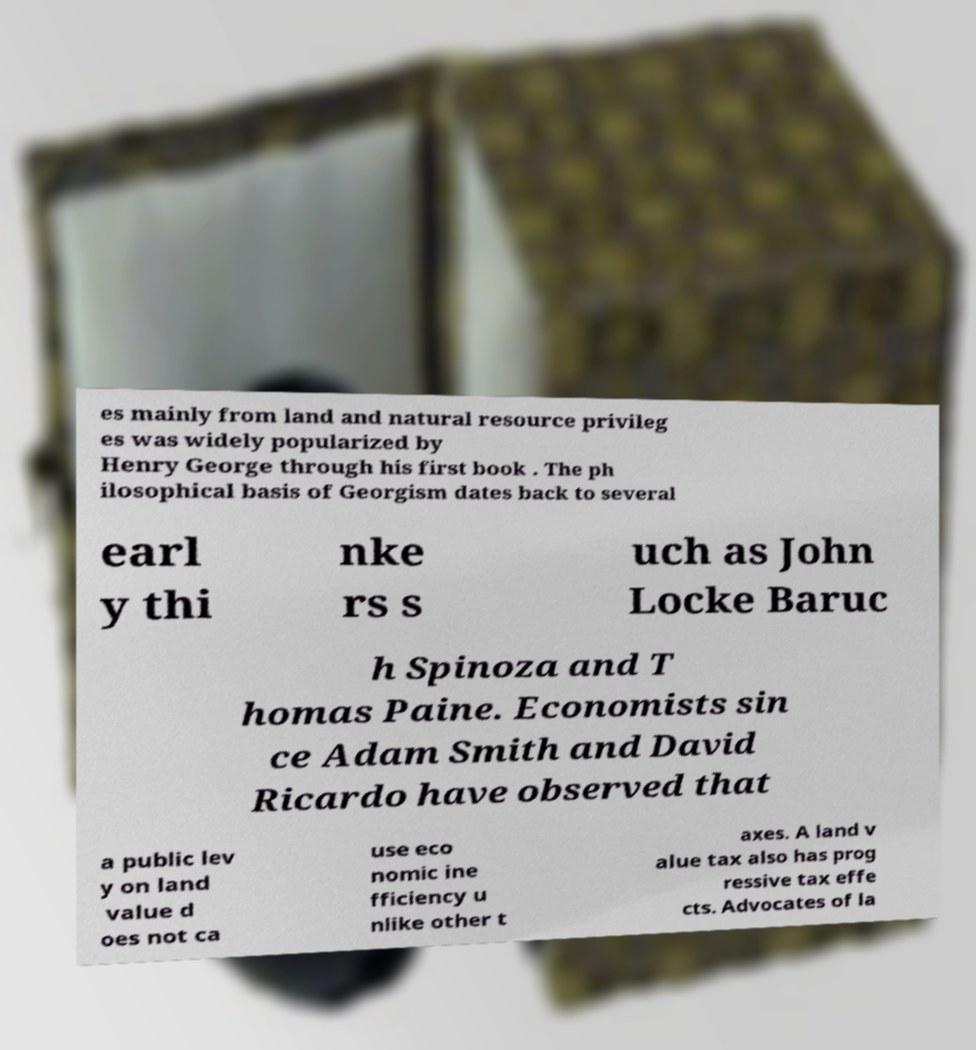For documentation purposes, I need the text within this image transcribed. Could you provide that? es mainly from land and natural resource privileg es was widely popularized by Henry George through his first book . The ph ilosophical basis of Georgism dates back to several earl y thi nke rs s uch as John Locke Baruc h Spinoza and T homas Paine. Economists sin ce Adam Smith and David Ricardo have observed that a public lev y on land value d oes not ca use eco nomic ine fficiency u nlike other t axes. A land v alue tax also has prog ressive tax effe cts. Advocates of la 